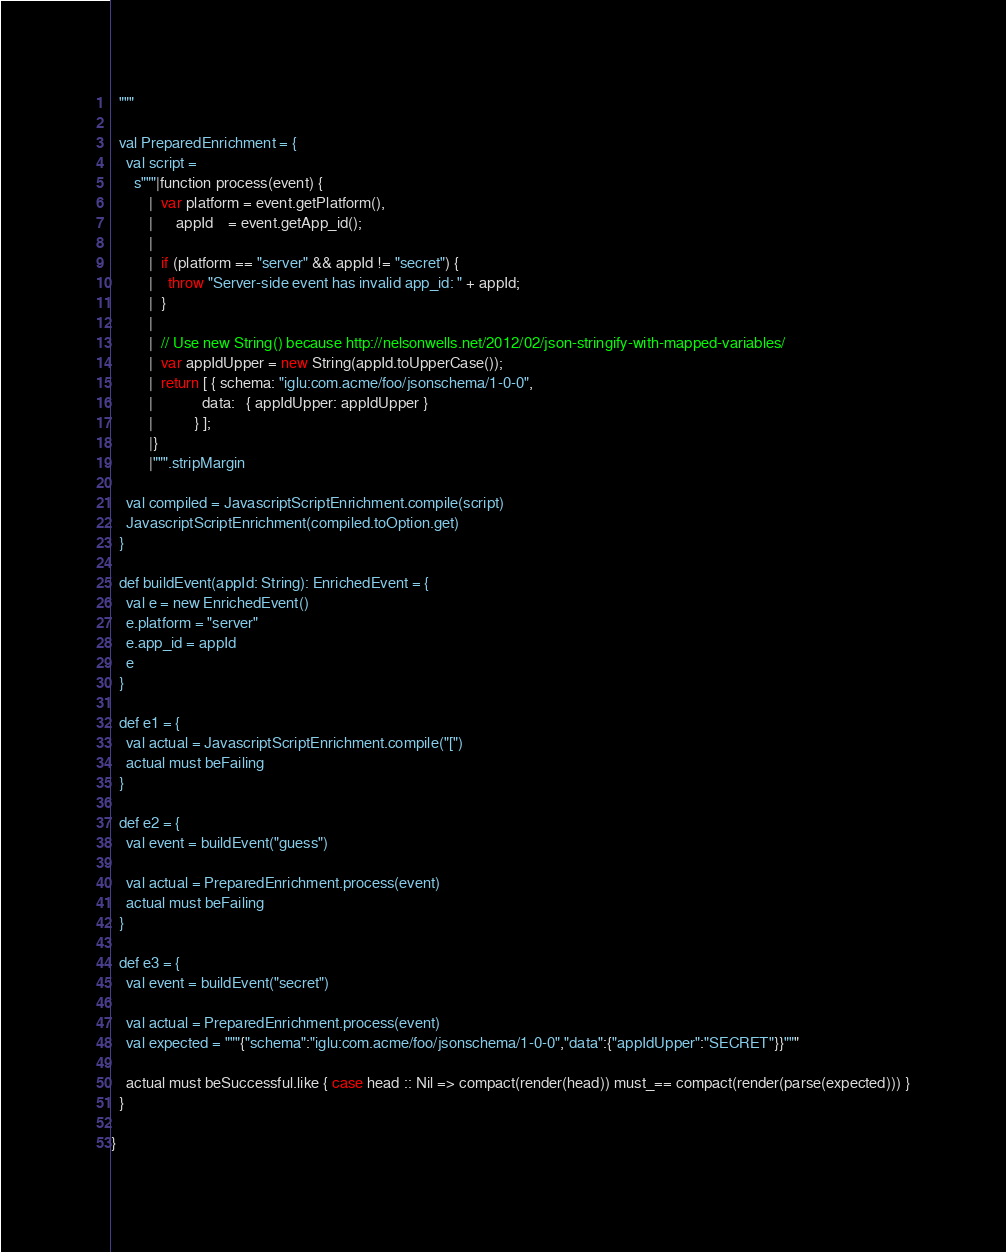<code> <loc_0><loc_0><loc_500><loc_500><_Scala_>  """

  val PreparedEnrichment = {
    val script =
      s"""|function process(event) {
          |  var platform = event.getPlatform(),
          |      appId    = event.getApp_id();
          |
          |  if (platform == "server" && appId != "secret") {
          |    throw "Server-side event has invalid app_id: " + appId;
          |  }
          |
          |  // Use new String() because http://nelsonwells.net/2012/02/json-stringify-with-mapped-variables/
          |  var appIdUpper = new String(appId.toUpperCase());
          |  return [ { schema: "iglu:com.acme/foo/jsonschema/1-0-0",
          |             data:   { appIdUpper: appIdUpper }
          |           } ];
          |}
          |""".stripMargin

    val compiled = JavascriptScriptEnrichment.compile(script)
    JavascriptScriptEnrichment(compiled.toOption.get)
  }

  def buildEvent(appId: String): EnrichedEvent = {
    val e = new EnrichedEvent()
    e.platform = "server"
    e.app_id = appId
    e
  }

  def e1 = {
    val actual = JavascriptScriptEnrichment.compile("[")
    actual must beFailing
  }

  def e2 = {
    val event = buildEvent("guess")

    val actual = PreparedEnrichment.process(event)
    actual must beFailing
  }

  def e3 = {
    val event = buildEvent("secret")

    val actual = PreparedEnrichment.process(event)
    val expected = """{"schema":"iglu:com.acme/foo/jsonschema/1-0-0","data":{"appIdUpper":"SECRET"}}"""

    actual must beSuccessful.like { case head :: Nil => compact(render(head)) must_== compact(render(parse(expected))) }
  }

}
</code> 